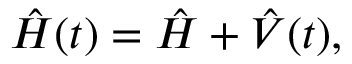<formula> <loc_0><loc_0><loc_500><loc_500>\begin{array} { r } { \hat { H } ( t ) = \hat { H } + \hat { V } ( t ) , } \end{array}</formula> 